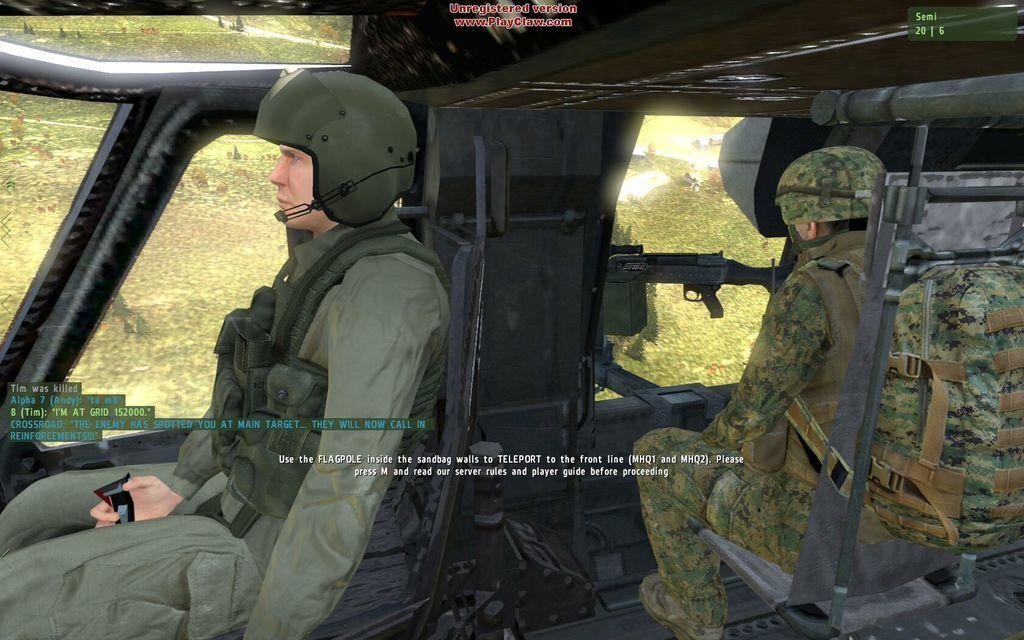Describe this image in one or two sentences. In this image it looks like an animation image in which there are two military persons sitting in the vehicle. In front of them there are guns. 